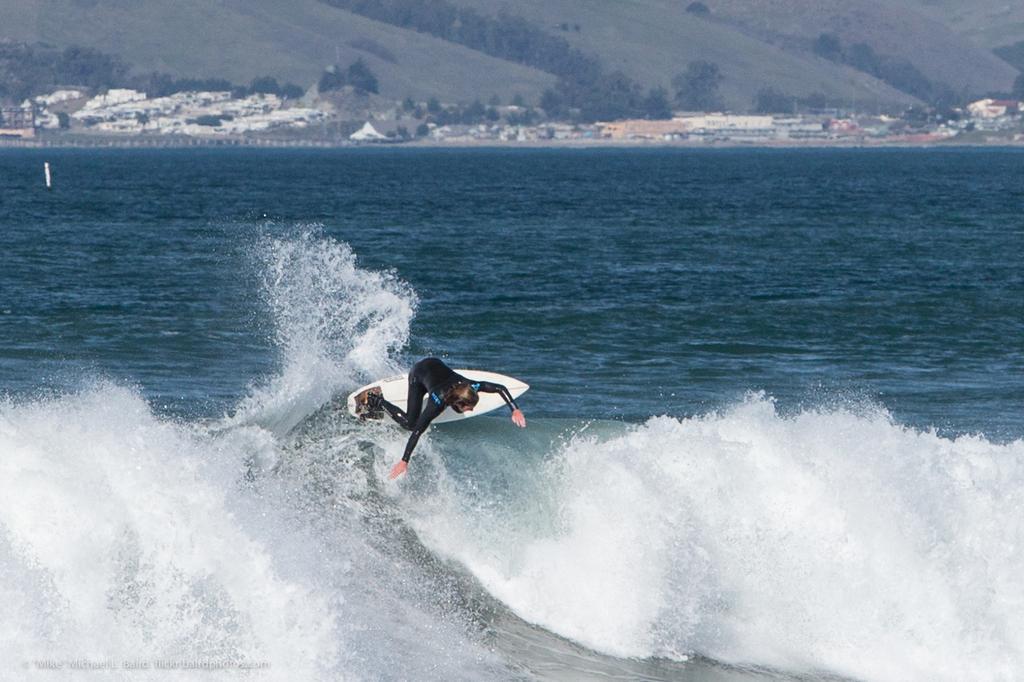How would you summarize this image in a sentence or two? In this image I can see a person is surfing in the sea, this person wore black color dress. At the top there are houses and trees. 